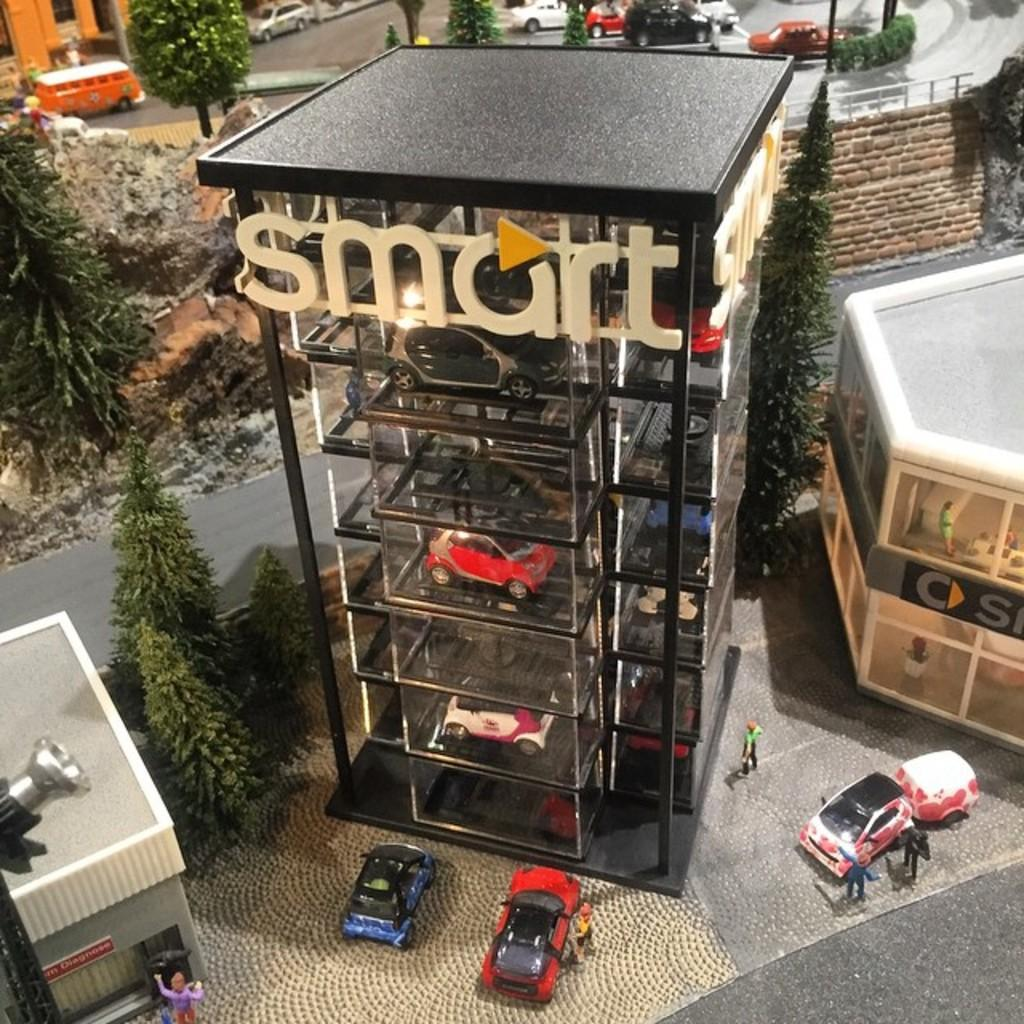What can be seen on the road in the image? There are cars on the road in the image. Where else can cars be found in the image? Cars can also be found in a building in the image. What is located beside the building in the image? There are trees and houses beside the building in the image. What type of silk is draped over the cars in the building? There is no silk present in the image; it only features cars on the road and in a building, along with trees and houses beside the building. 